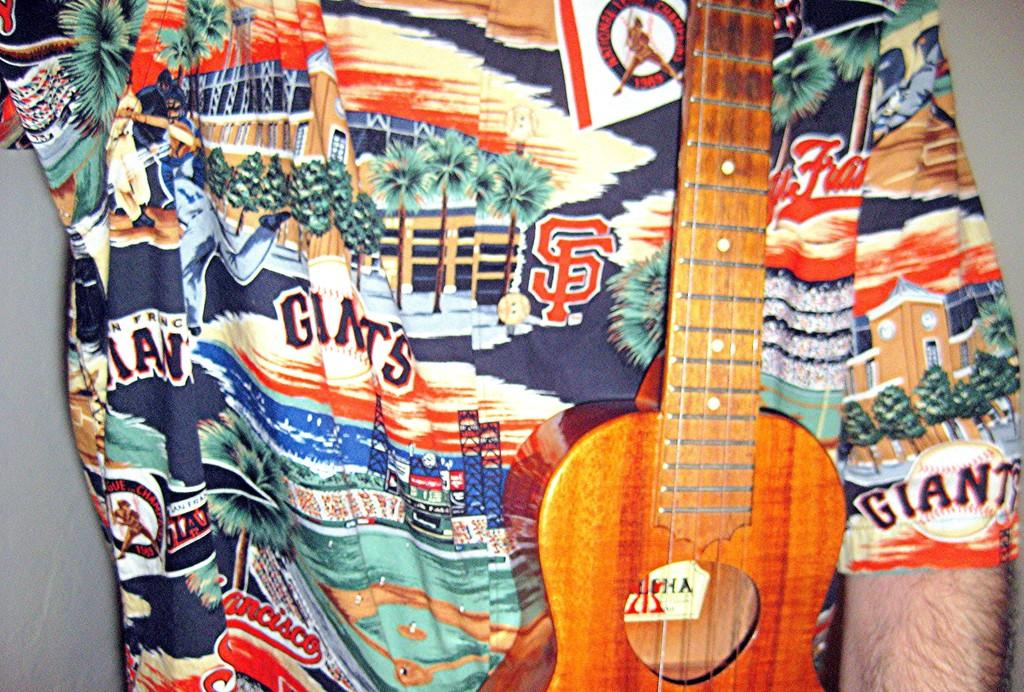What is the main subject of the image? There is a man in the image. What is the man holding in the image? The man is holding a guitar. What type of crack is visible in the scene in the image? There is no crack visible in the image, as it features a man holding a guitar. What word is written on the guitar in the image? There is no word written on the guitar in the image; it is not mentioned in the provided facts. 